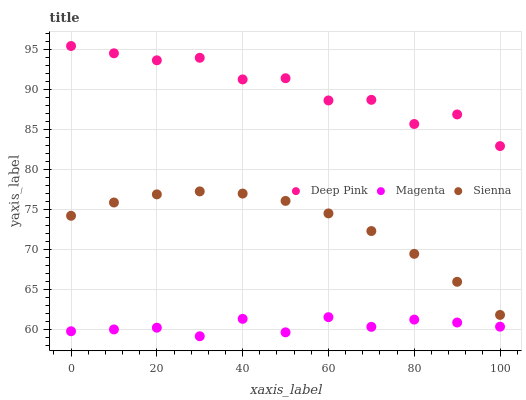Does Magenta have the minimum area under the curve?
Answer yes or no. Yes. Does Deep Pink have the maximum area under the curve?
Answer yes or no. Yes. Does Deep Pink have the minimum area under the curve?
Answer yes or no. No. Does Magenta have the maximum area under the curve?
Answer yes or no. No. Is Sienna the smoothest?
Answer yes or no. Yes. Is Deep Pink the roughest?
Answer yes or no. Yes. Is Magenta the smoothest?
Answer yes or no. No. Is Magenta the roughest?
Answer yes or no. No. Does Magenta have the lowest value?
Answer yes or no. Yes. Does Deep Pink have the lowest value?
Answer yes or no. No. Does Deep Pink have the highest value?
Answer yes or no. Yes. Does Magenta have the highest value?
Answer yes or no. No. Is Magenta less than Sienna?
Answer yes or no. Yes. Is Deep Pink greater than Sienna?
Answer yes or no. Yes. Does Magenta intersect Sienna?
Answer yes or no. No. 